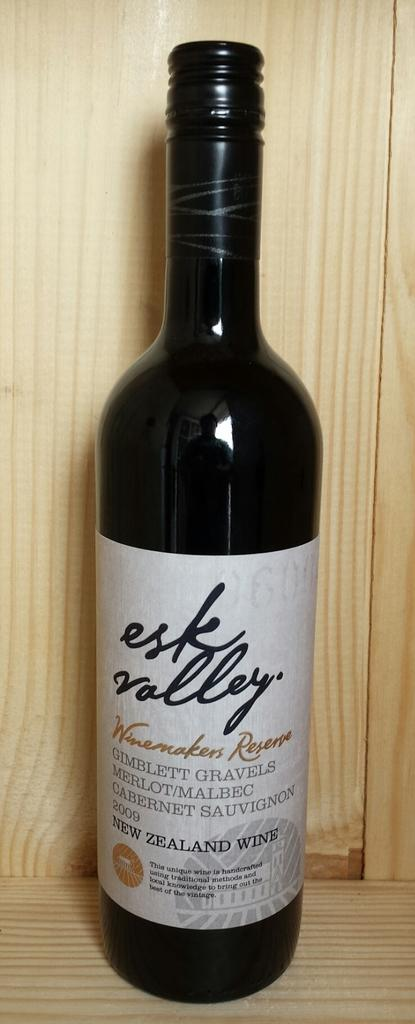<image>
Relay a brief, clear account of the picture shown. Bottle of New ZealandWine esk valley that is new 